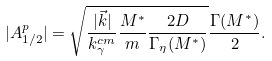Convert formula to latex. <formula><loc_0><loc_0><loc_500><loc_500>| A _ { 1 / 2 } ^ { p } | = \sqrt { \frac { | \vec { k } | } { k _ { \gamma } ^ { c m } } \frac { M ^ { * } } { m } \frac { 2 D } { \Gamma _ { \eta } ( M ^ { * } ) } } \frac { \Gamma ( M ^ { * } ) } { 2 } .</formula> 